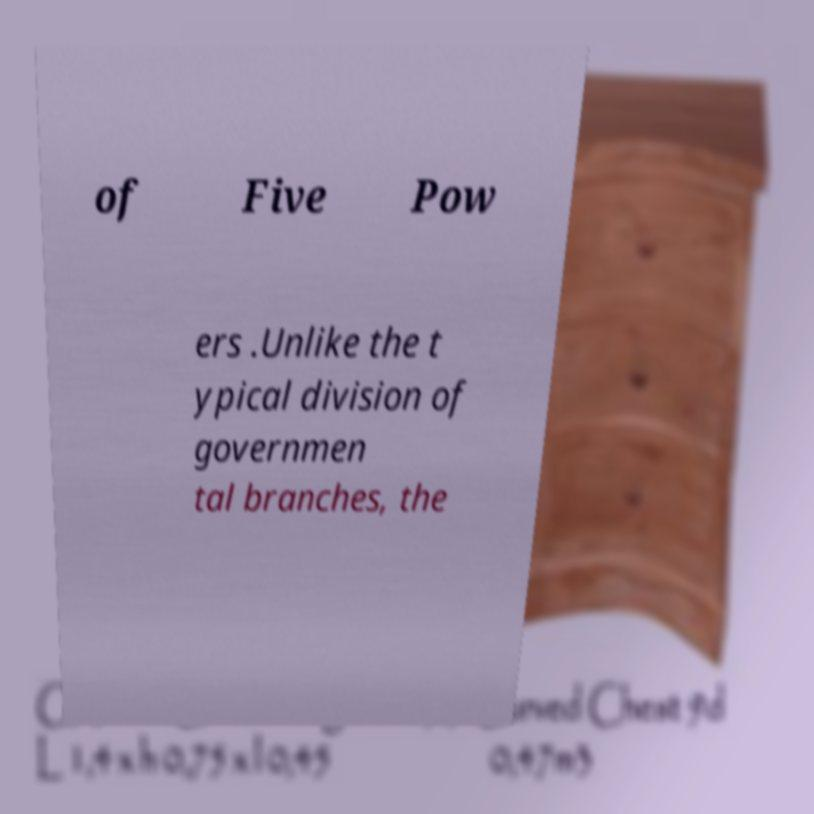Could you extract and type out the text from this image? of Five Pow ers .Unlike the t ypical division of governmen tal branches, the 